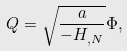Convert formula to latex. <formula><loc_0><loc_0><loc_500><loc_500>Q = \sqrt { \frac { a } { - H _ { , N } } } \Phi ,</formula> 